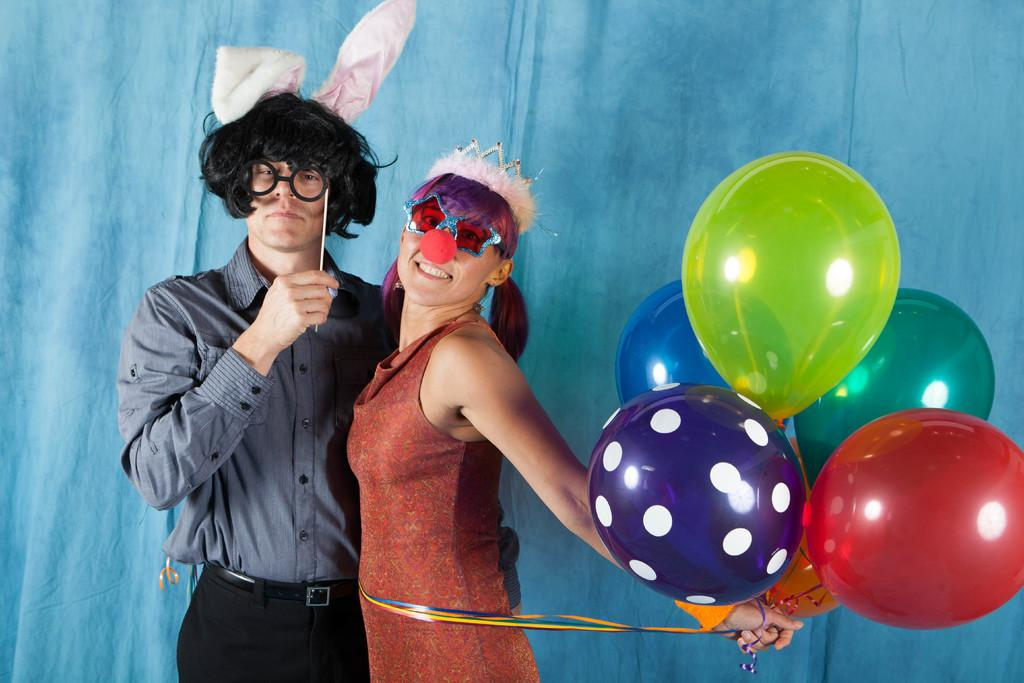What is happening in the image? There are people standing in the image, including a woman holding ribbons with balloons. Can you describe the woman's appearance? The woman is wearing a clown nose, a crown, and goggles. What color is the background of the image? The background of the image is blue. What type of advertisement is the woman promoting in the image? There is no advertisement present in the image; it simply features a woman holding ribbons with balloons. Can you tell me how many worms are crawling on the woman's shoes in the image? There are no worms present in the image; the focus is on the woman and her attire. 